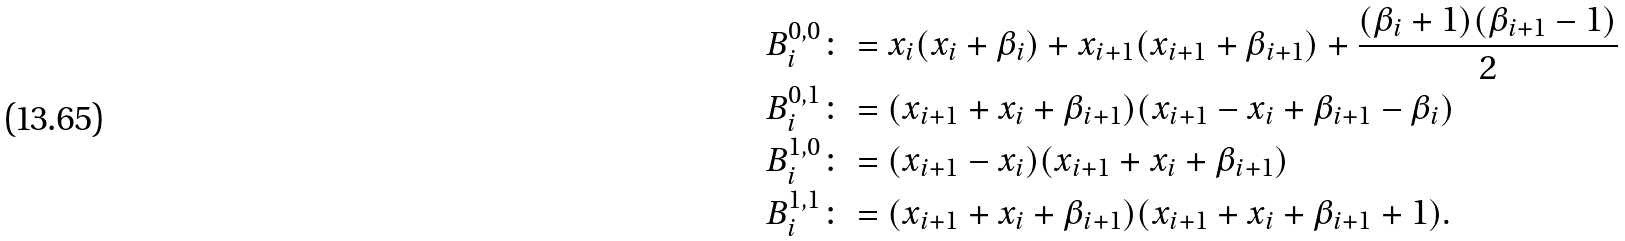Convert formula to latex. <formula><loc_0><loc_0><loc_500><loc_500>B _ { i } ^ { 0 , 0 } & \colon = x _ { i } ( x _ { i } + \beta _ { i } ) + x _ { i + 1 } ( x _ { i + 1 } + \beta _ { i + 1 } ) + \frac { ( \beta _ { i } + 1 ) ( \beta _ { i + 1 } - 1 ) } { 2 } \\ B _ { i } ^ { 0 , 1 } & \colon = ( x _ { i + 1 } + x _ { i } + \beta _ { i + 1 } ) ( x _ { i + 1 } - x _ { i } + \beta _ { i + 1 } - \beta _ { i } ) \\ B _ { i } ^ { 1 , 0 } & \colon = ( x _ { i + 1 } - x _ { i } ) ( x _ { i + 1 } + x _ { i } + \beta _ { i + 1 } ) \\ B _ { i } ^ { 1 , 1 } & \colon = ( x _ { i + 1 } + x _ { i } + \beta _ { i + 1 } ) ( x _ { i + 1 } + x _ { i } + \beta _ { i + 1 } + 1 ) .</formula> 